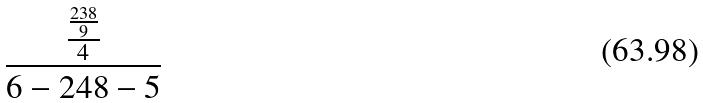<formula> <loc_0><loc_0><loc_500><loc_500>\frac { \frac { \frac { 2 3 8 } { 9 } } { 4 } } { 6 - 2 4 8 - 5 }</formula> 